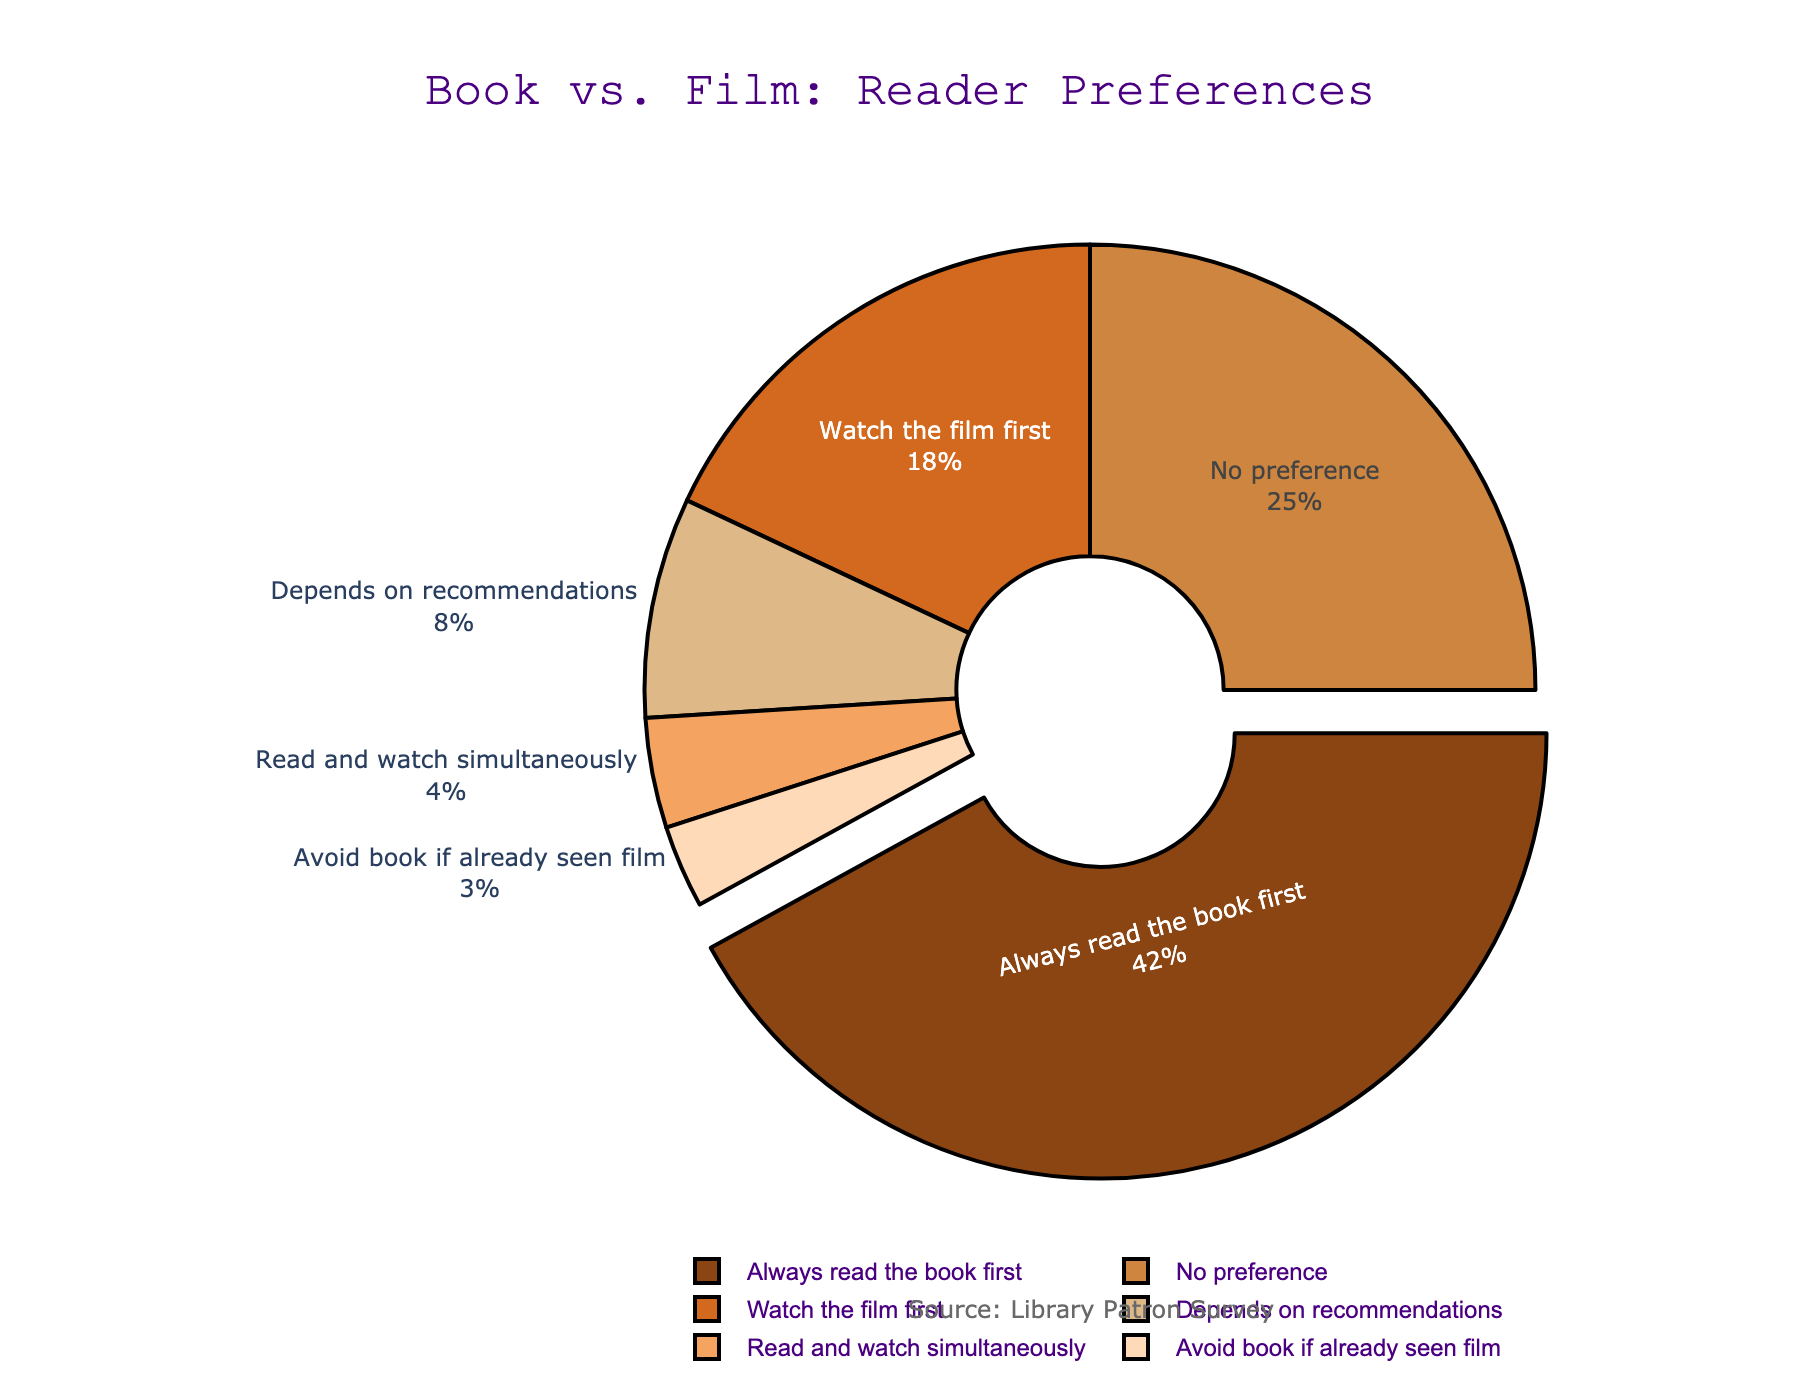what proportion of patrons prefer watching the film first compared to reading and watching simultaneously? The percentage of patrons who prefer watching the film first is 18%, and the percentage who read and watch simultaneously is 4%. To find the proportion, divide 18% by 4%.
Answer: 4.5 which preference has the highest percentage? The figure shows that the preference with the highest percentage is "Always read the book first" at 42%.
Answer: Always read the book first what is the total percentage of patrons who have no preference or avoid the book if they've already seen the film? To find the total percentage, add the percentages of "No preference" (25%) and "Avoid book if already seen film" (3%).
Answer: 28% how much larger is the percentage of patrons who always read the book first compared to those who depend on recommendations? The percentage of patrons who always read the book first is 42%, and those who depend on recommendations is 8%. Subtract 8% from 42%.
Answer: 34% out of the given categories, which has the smallest percentage, and what is that percentage? According to the figure, "Avoid book if already seen film" has the smallest percentage at 3%.
Answer: Avoid book if already seen film, 3% what is the combined percentage of patrons who either always read the book first or have no preference? To find the combined percentage, add the percentages of "Always read the book first" (42%) and "No preference" (25%).
Answer: 67% how does the percentage of patrons who read and watch simultaneously compare to those who watch the film first? The percentage of patrons who read and watch simultaneously is 4%, whereas those who watch the film first is 18%. Subtract 4% from 18%.
Answer: 14% greater what is the median value of patron preferences? To find the median value, list the percentages in order: 3, 4, 8, 18, 25, and 42%. The median is the average of the two middle values (8+18)/2.
Answer: 13% what percentage of patrons have a definite preference (either always read the book first or watch the film first)? To find the percentage of patrons with a definite preference, add the percentages of "Always read the book first" (42%) and "Watch the film first" (18%).
Answer: 60% Which color represents the "Depends on recommendations" preference? According to the data and the expected sequence of colors, the "Depends on recommendations" preference is represented by the fourth color in the order, which is a yellowish-brown color.
Answer: yellowish-brown 